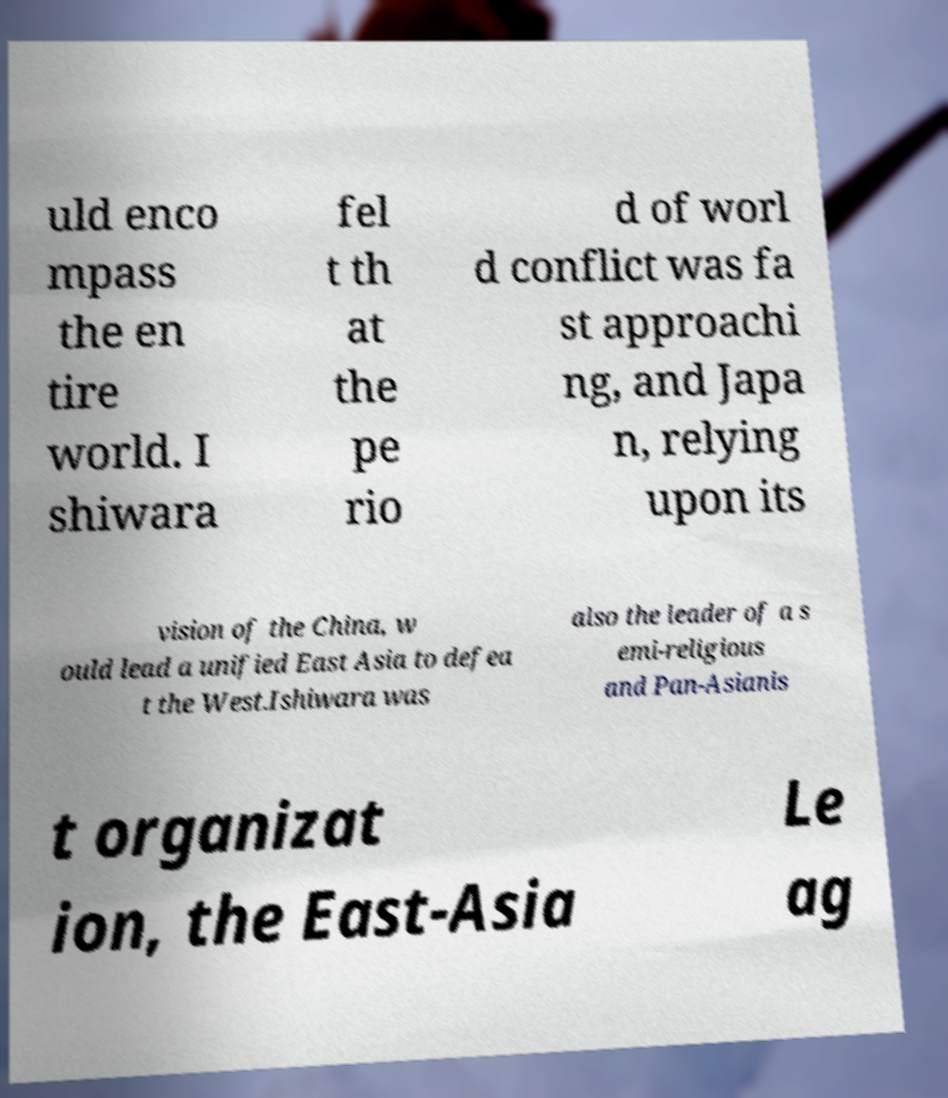Can you read and provide the text displayed in the image?This photo seems to have some interesting text. Can you extract and type it out for me? uld enco mpass the en tire world. I shiwara fel t th at the pe rio d of worl d conflict was fa st approachi ng, and Japa n, relying upon its vision of the China, w ould lead a unified East Asia to defea t the West.Ishiwara was also the leader of a s emi-religious and Pan-Asianis t organizat ion, the East-Asia Le ag 